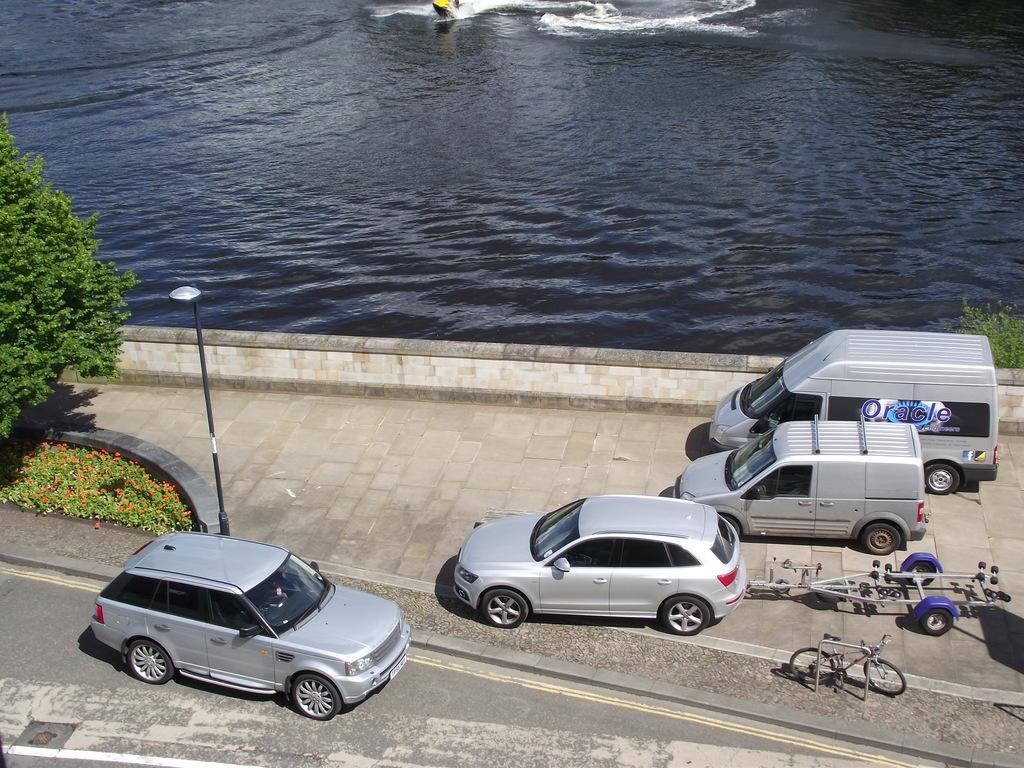In one or two sentences, can you explain what this image depicts? At the bottom of the image we can see some vehicles on the road and we can see some bicycles, poles, trees and plants. At the top of the image we can see water, above the water we can see a water boat. 